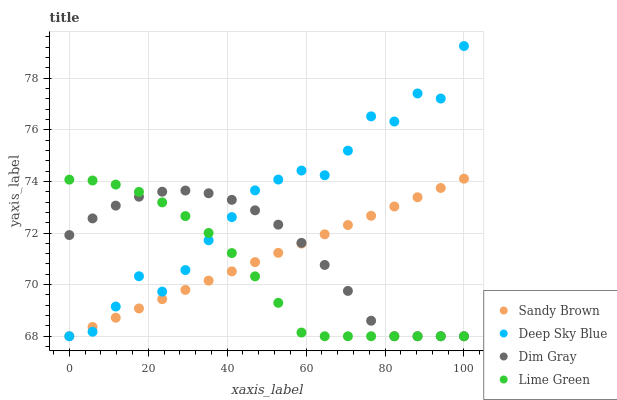Does Lime Green have the minimum area under the curve?
Answer yes or no. Yes. Does Deep Sky Blue have the maximum area under the curve?
Answer yes or no. Yes. Does Dim Gray have the minimum area under the curve?
Answer yes or no. No. Does Dim Gray have the maximum area under the curve?
Answer yes or no. No. Is Sandy Brown the smoothest?
Answer yes or no. Yes. Is Deep Sky Blue the roughest?
Answer yes or no. Yes. Is Dim Gray the smoothest?
Answer yes or no. No. Is Dim Gray the roughest?
Answer yes or no. No. Does Lime Green have the lowest value?
Answer yes or no. Yes. Does Deep Sky Blue have the highest value?
Answer yes or no. Yes. Does Sandy Brown have the highest value?
Answer yes or no. No. Does Lime Green intersect Dim Gray?
Answer yes or no. Yes. Is Lime Green less than Dim Gray?
Answer yes or no. No. Is Lime Green greater than Dim Gray?
Answer yes or no. No. 